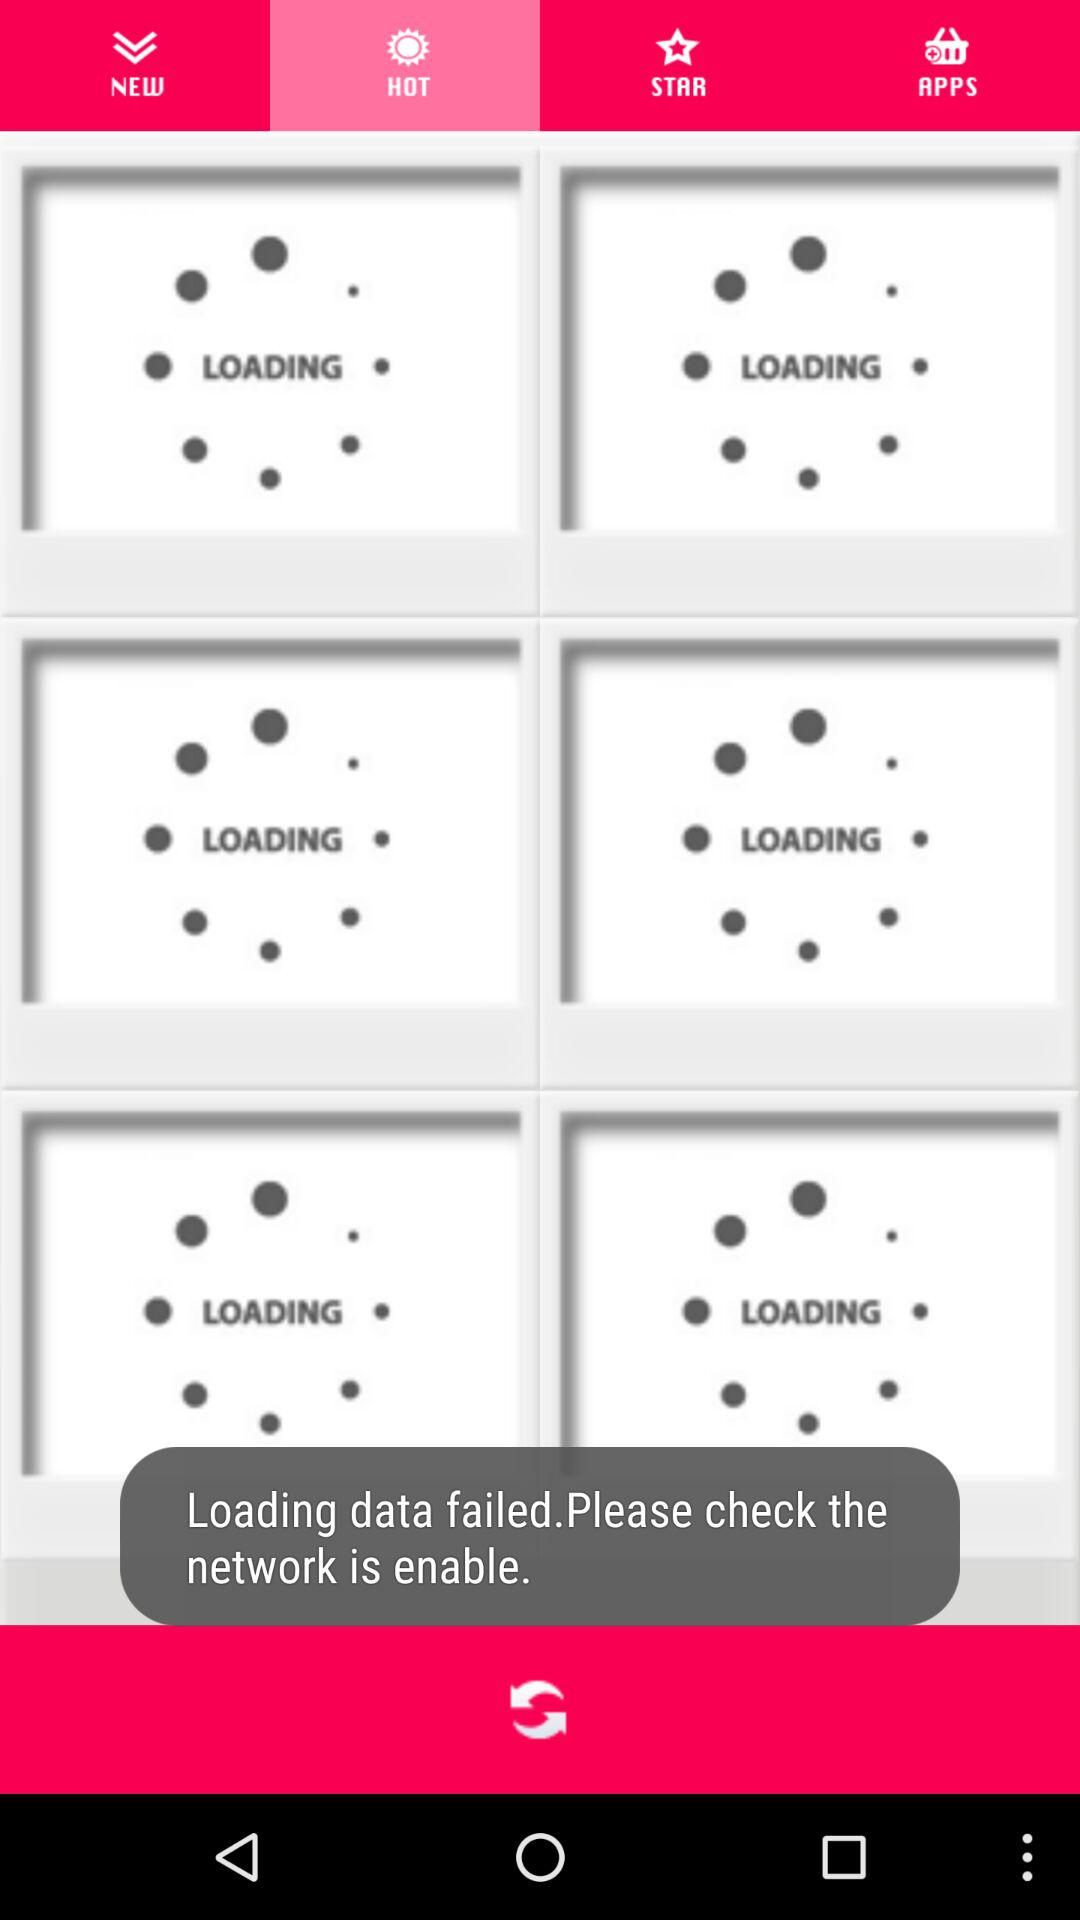What is the selected tab? The selected tab is "HOT". 